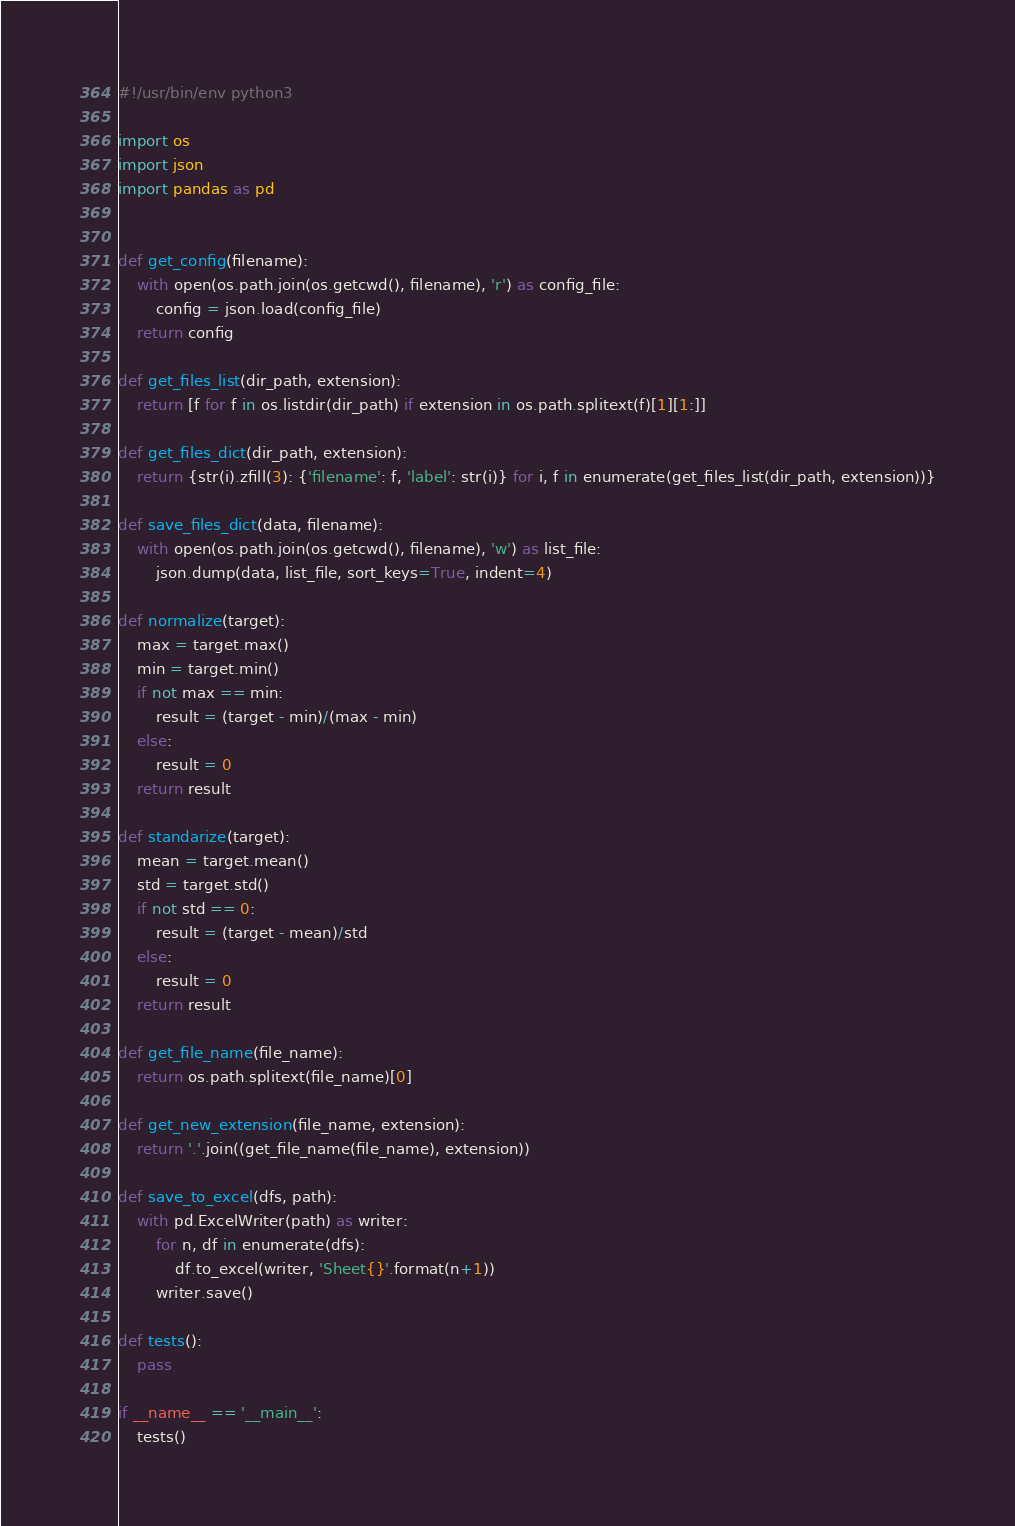<code> <loc_0><loc_0><loc_500><loc_500><_Python_>#!/usr/bin/env python3

import os
import json
import pandas as pd


def get_config(filename):
    with open(os.path.join(os.getcwd(), filename), 'r') as config_file:
        config = json.load(config_file)
    return config

def get_files_list(dir_path, extension):
    return [f for f in os.listdir(dir_path) if extension in os.path.splitext(f)[1][1:]]

def get_files_dict(dir_path, extension):
    return {str(i).zfill(3): {'filename': f, 'label': str(i)} for i, f in enumerate(get_files_list(dir_path, extension))}

def save_files_dict(data, filename):
    with open(os.path.join(os.getcwd(), filename), 'w') as list_file:
        json.dump(data, list_file, sort_keys=True, indent=4)

def normalize(target):
    max = target.max()
    min = target.min()
    if not max == min:
        result = (target - min)/(max - min)
    else:
        result = 0
    return result

def standarize(target):
    mean = target.mean()
    std = target.std()
    if not std == 0:
        result = (target - mean)/std
    else:
        result = 0
    return result

def get_file_name(file_name):
    return os.path.splitext(file_name)[0]

def get_new_extension(file_name, extension):
    return '.'.join((get_file_name(file_name), extension))

def save_to_excel(dfs, path):
    with pd.ExcelWriter(path) as writer:
        for n, df in enumerate(dfs):
            df.to_excel(writer, 'Sheet{}'.format(n+1))
        writer.save()

def tests():
    pass

if __name__ == '__main__':
    tests()
</code> 